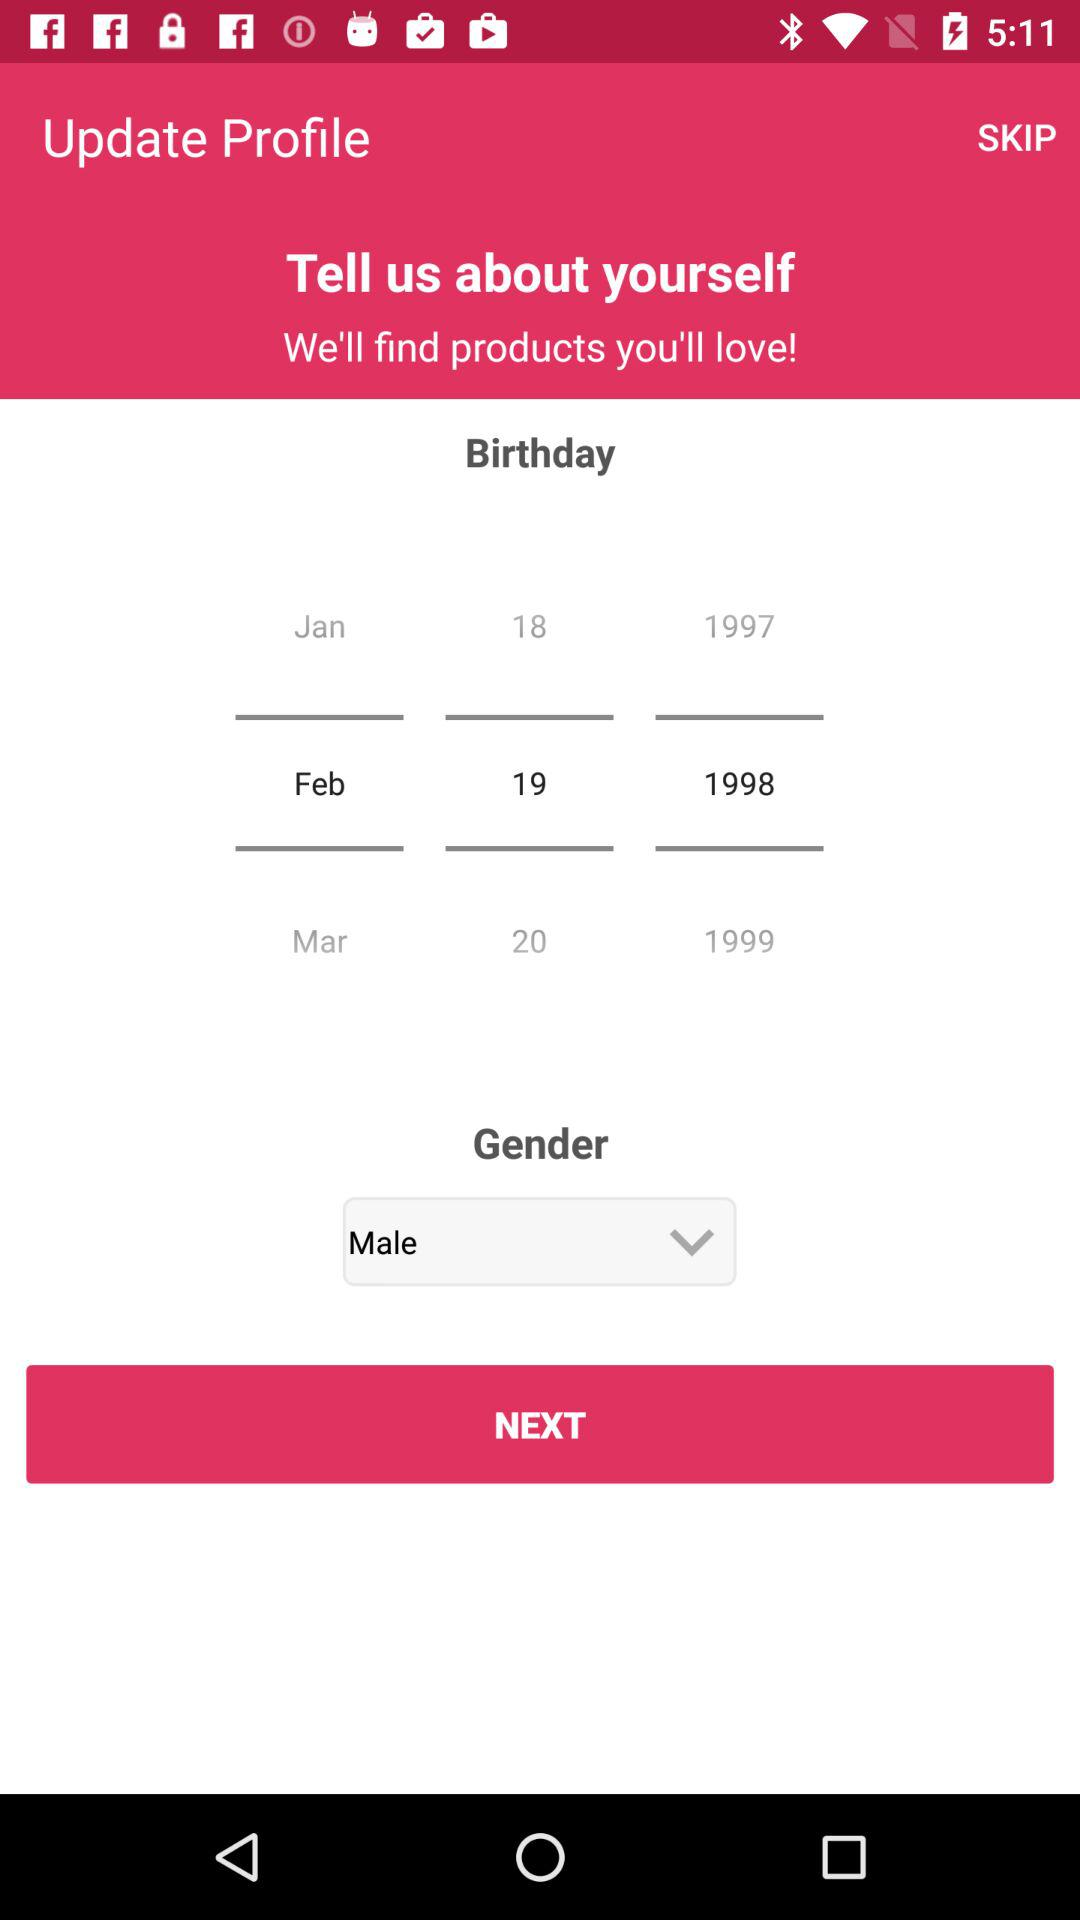What is the gender of the person? The gender of the person is male. 